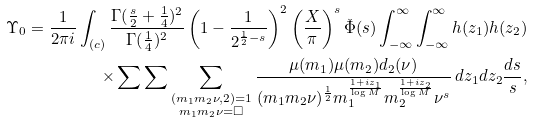Convert formula to latex. <formula><loc_0><loc_0><loc_500><loc_500>\Upsilon _ { 0 } = \frac { 1 } { 2 \pi i } \int _ { ( c ) } \frac { \Gamma ( \frac { s } { 2 } + \frac { 1 } { 4 } ) ^ { 2 } } { \Gamma ( \frac { 1 } { 4 } ) ^ { 2 } } \left ( 1 - \frac { 1 } { 2 ^ { \frac { 1 } { 2 } - s } } \right ) ^ { 2 } \left ( \frac { X } { \pi } \right ) ^ { s } \check { \Phi } ( s ) \int _ { - \infty } ^ { \infty } \int _ { - \infty } ^ { \infty } h ( z _ { 1 } ) h ( z _ { 2 } ) \\ \times \sum \sum \sum _ { \substack { ( m _ { 1 } m _ { 2 } \nu , 2 ) = 1 \\ m _ { 1 } m _ { 2 } \nu = \square } } \frac { \mu ( m _ { 1 } ) \mu ( m _ { 2 } ) d _ { 2 } ( \nu ) } { ( m _ { 1 } m _ { 2 } \nu ) ^ { \frac { 1 } { 2 } } m _ { 1 } ^ { \frac { 1 + i z _ { 1 } } { \log M } } m _ { 2 } ^ { \frac { 1 + i z _ { 2 } } { \log M } } \nu ^ { s } } \, d z _ { 1 } d z _ { 2 } \frac { d s } { s } ,</formula> 